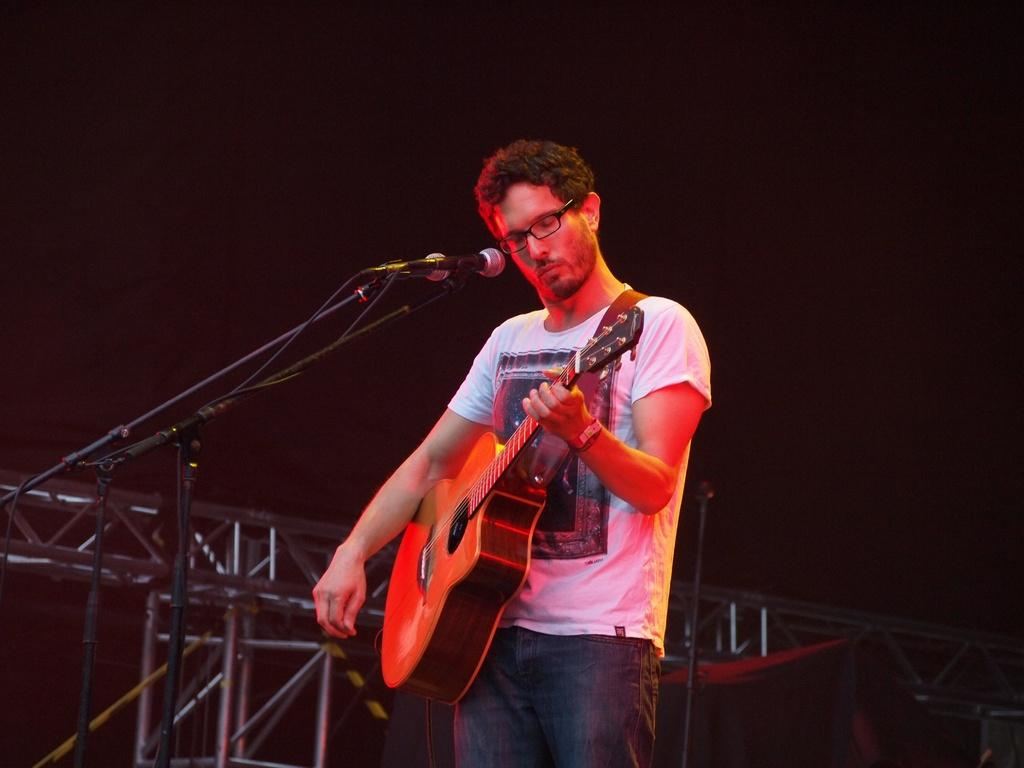Who is the main subject in the image? There is a man in the image. Where is the man positioned in the image? The man is standing in the middle of the image. What is the man wearing in the image? The man is wearing a white t-shirt. What is the man doing in the image? The man is playing a guitar. What accessory is the man wearing in the image? The man is wearing spectacles. What type of pancake is the man flipping in the image? There is no pancake present in the image; the man is playing a guitar. 